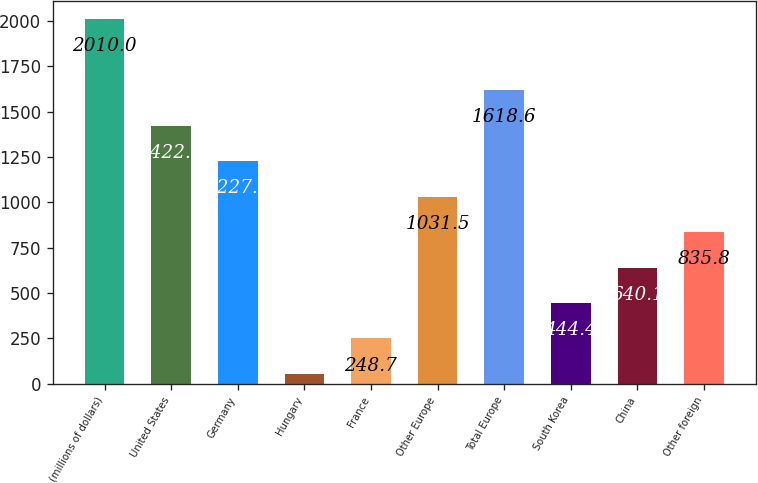Convert chart to OTSL. <chart><loc_0><loc_0><loc_500><loc_500><bar_chart><fcel>(millions of dollars)<fcel>United States<fcel>Germany<fcel>Hungary<fcel>France<fcel>Other Europe<fcel>Total Europe<fcel>South Korea<fcel>China<fcel>Other foreign<nl><fcel>2010<fcel>1422.9<fcel>1227.2<fcel>53<fcel>248.7<fcel>1031.5<fcel>1618.6<fcel>444.4<fcel>640.1<fcel>835.8<nl></chart> 